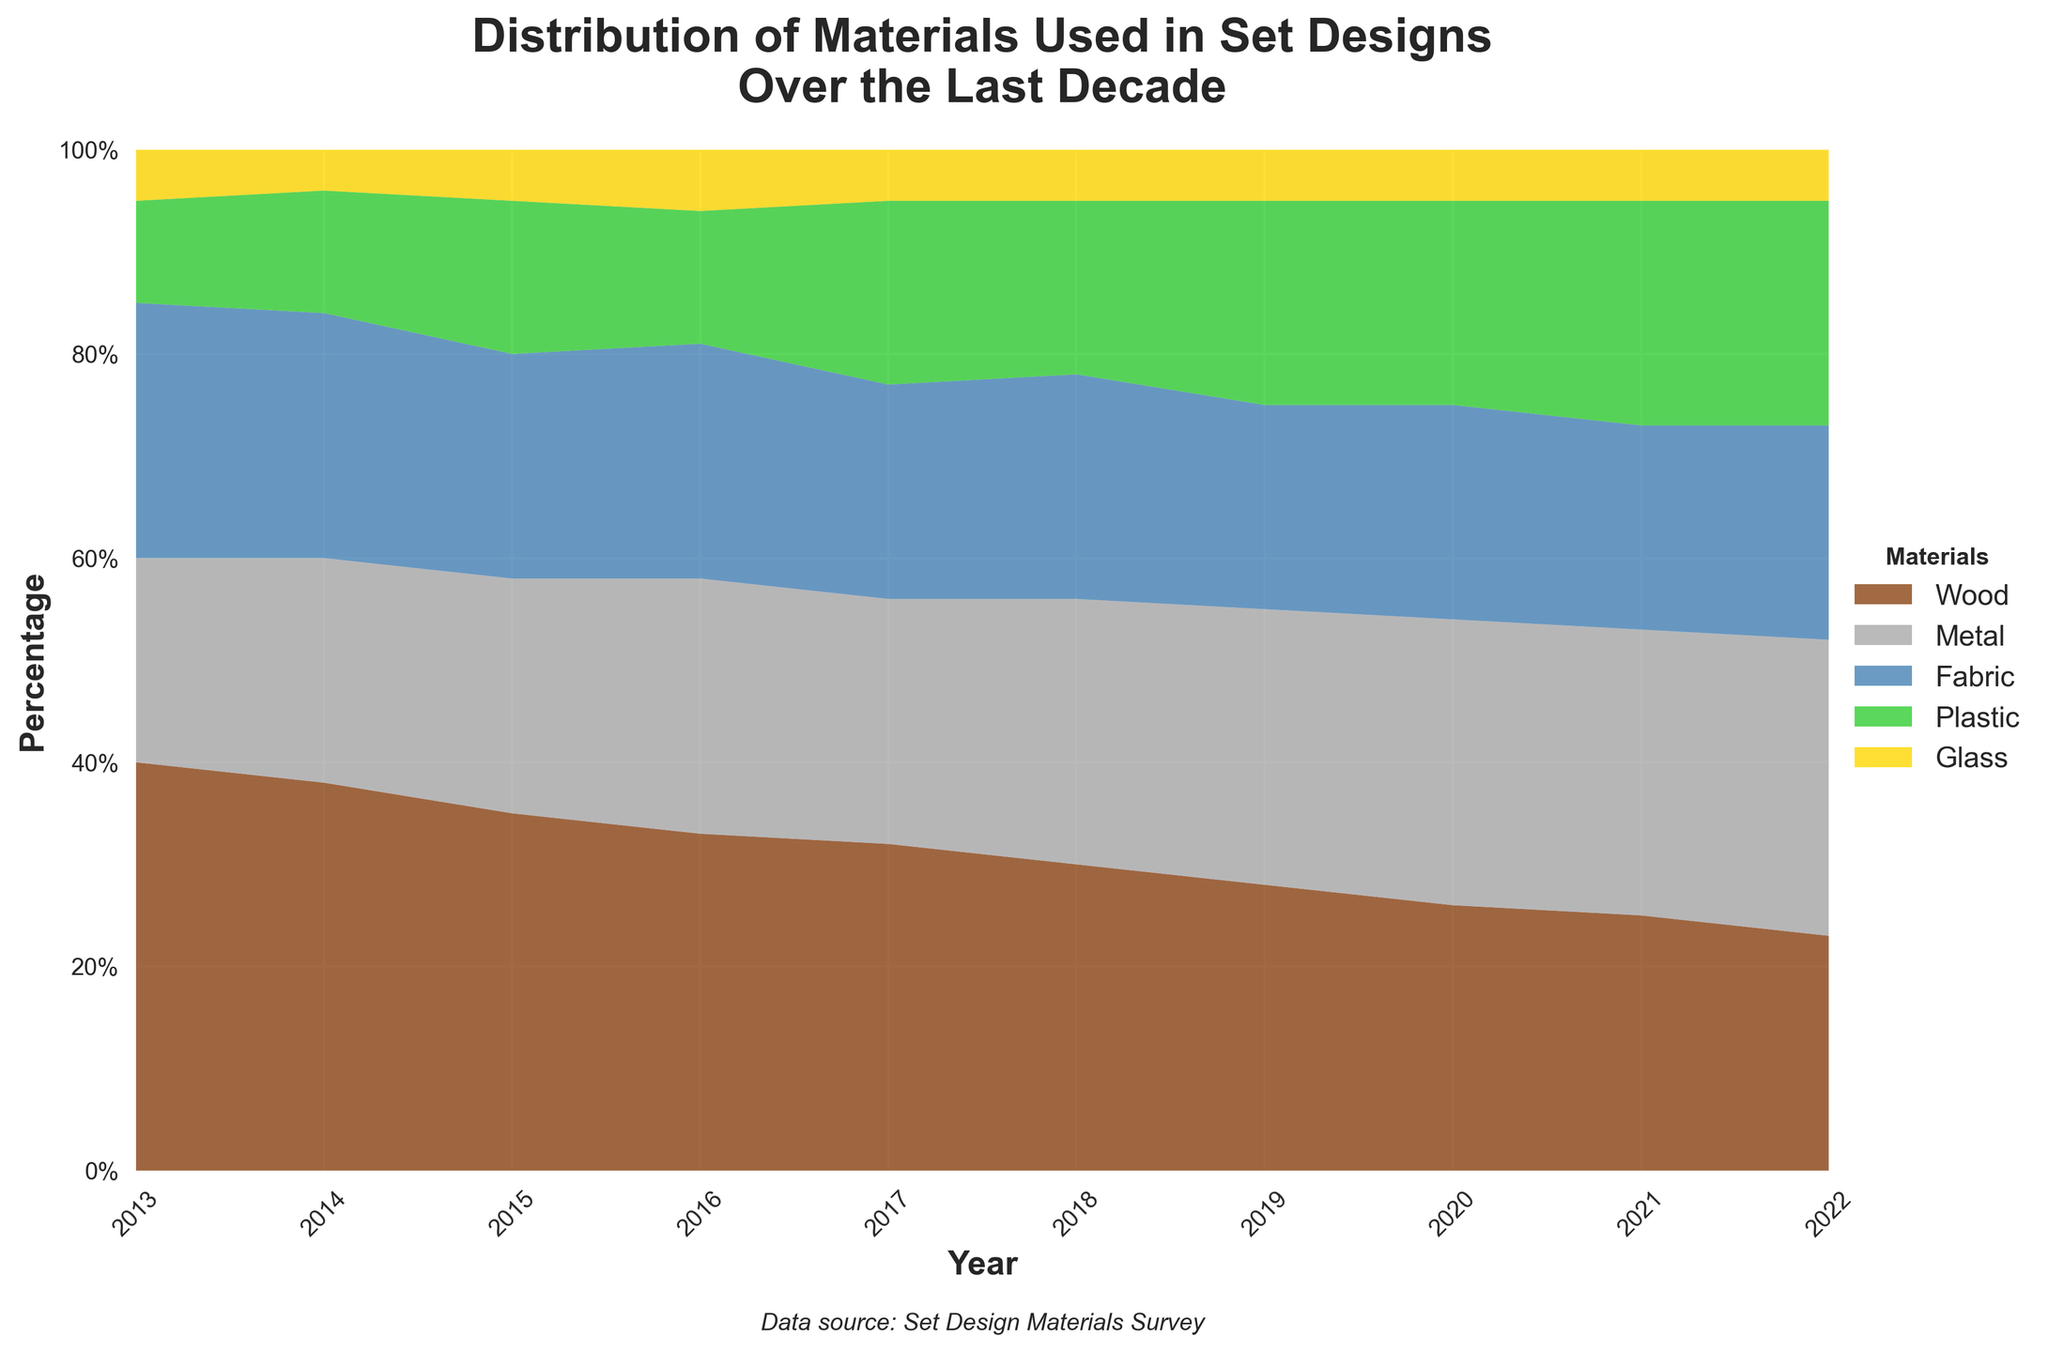What is the title of the chart? The title is located at the top of the chart and reads: “Distribution of Materials Used in Set Designs Over the Last Decade.”
Answer: Distribution of Materials Used in Set Designs Over the Last Decade How many types of materials are tracked in the chart? The legend on the right side of the chart lists each type of material used in the set design. They include Wood, Metal, Fabric, Plastic, and Glass, adding up to five types.
Answer: Five In which year did Wood have its highest usage percentage? The stacked area for Wood, which is represented by the brown color, is tallest in 2013.
Answer: 2013 Between 2013 and 2022, how did the percentage use of Plastic change? The green area representing Plastic increases in size from 10% in 2013 to 22% in 2022, indicating an increase.
Answer: Increased Which material had the most constant percentage usage over the decade? By observing the consistent height of the yellow area chart, representing Glass, it remains relatively steady at 5% across all years.
Answer: Glass In 2021, which materials had higher usage percentages than Fabric? In 2021, the height of the areas for Wood, Metal, and Plastic are above the height of the blue area for Fabric, indicating higher percentages.
Answer: Wood, Metal, Plastic Between which two years did Metal see the most significant increase in percentage usage? By comparing the grey area representing Metal, from 2013 to 2022, the sharpest increase happens between 2013 (20%) and 2022 (29%). However, the actual significant jump happens between 2019 (27%) and 2020 (28%), though it appears more gradually over time.
Answer: 2013 and 2022 What was the least used material in 2015? The yellow area representing Glass is the smallest in all years; hence, it is the least used material even in 2015.
Answer: Glass Did Wood’s usage percentage always decrease year over year? Observing the brown area for Wood from 2013 to 2022, it consistently decreases every year without any year-over-year increase.
Answer: Yes 